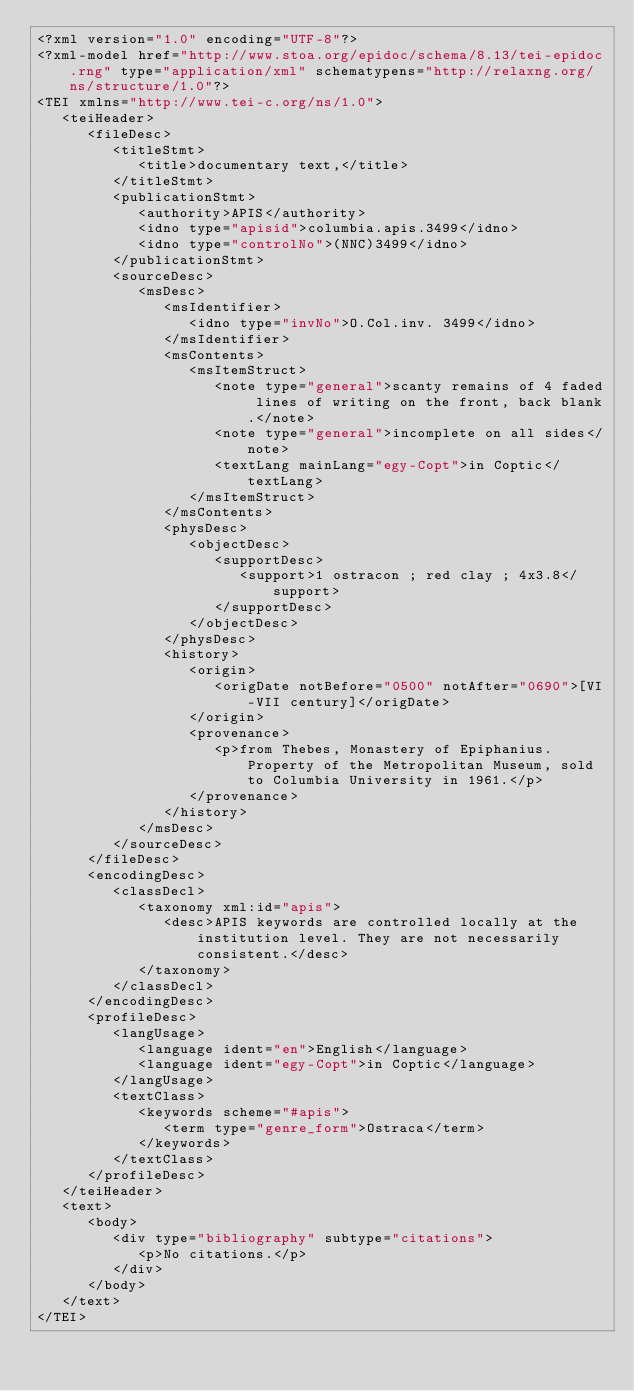Convert code to text. <code><loc_0><loc_0><loc_500><loc_500><_XML_><?xml version="1.0" encoding="UTF-8"?>
<?xml-model href="http://www.stoa.org/epidoc/schema/8.13/tei-epidoc.rng" type="application/xml" schematypens="http://relaxng.org/ns/structure/1.0"?>
<TEI xmlns="http://www.tei-c.org/ns/1.0">
   <teiHeader>
      <fileDesc>
         <titleStmt>
            <title>documentary text,</title>
         </titleStmt>
         <publicationStmt>
            <authority>APIS</authority>
            <idno type="apisid">columbia.apis.3499</idno>
            <idno type="controlNo">(NNC)3499</idno>
         </publicationStmt>
         <sourceDesc>
            <msDesc>
               <msIdentifier>
                  <idno type="invNo">O.Col.inv. 3499</idno>
               </msIdentifier>
               <msContents>
                  <msItemStruct>
                     <note type="general">scanty remains of 4 faded lines of writing on the front, back blank.</note>
                     <note type="general">incomplete on all sides</note>
                     <textLang mainLang="egy-Copt">in Coptic</textLang>
                  </msItemStruct>
               </msContents>
               <physDesc>
                  <objectDesc>
                     <supportDesc>
                        <support>1 ostracon ; red clay ; 4x3.8</support>
                     </supportDesc>
                  </objectDesc>
               </physDesc>
               <history>
                  <origin>
                     <origDate notBefore="0500" notAfter="0690">[VI-VII century]</origDate>
                  </origin>
                  <provenance>
                     <p>from Thebes, Monastery of Epiphanius.  Property of the Metropolitan Museum, sold to Columbia University in 1961.</p>
                  </provenance>
               </history>
            </msDesc>
         </sourceDesc>
      </fileDesc>
      <encodingDesc>
         <classDecl>
            <taxonomy xml:id="apis">
               <desc>APIS keywords are controlled locally at the institution level. They are not necessarily consistent.</desc>
            </taxonomy>
         </classDecl>
      </encodingDesc>
      <profileDesc>
         <langUsage>
            <language ident="en">English</language>
            <language ident="egy-Copt">in Coptic</language>
         </langUsage>
         <textClass>
            <keywords scheme="#apis">
               <term type="genre_form">Ostraca</term>
            </keywords>
         </textClass>
      </profileDesc>
   </teiHeader>
   <text>
      <body>
         <div type="bibliography" subtype="citations">
            <p>No citations.</p>
         </div>
      </body>
   </text>
</TEI>
</code> 